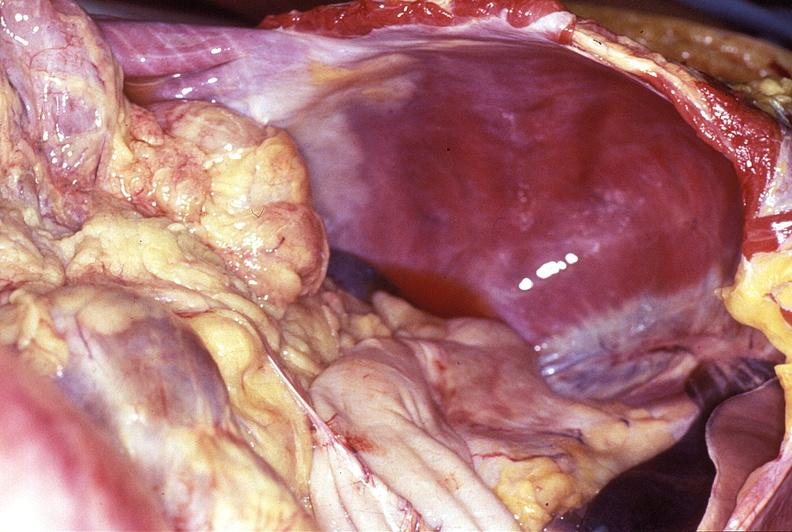s gout present?
Answer the question using a single word or phrase. No 